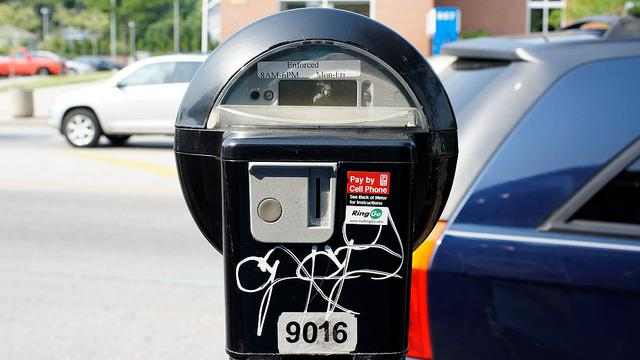What would someone need to do to use this device?

Choices:
A) ask
B) dance
C) crime
D) park park 